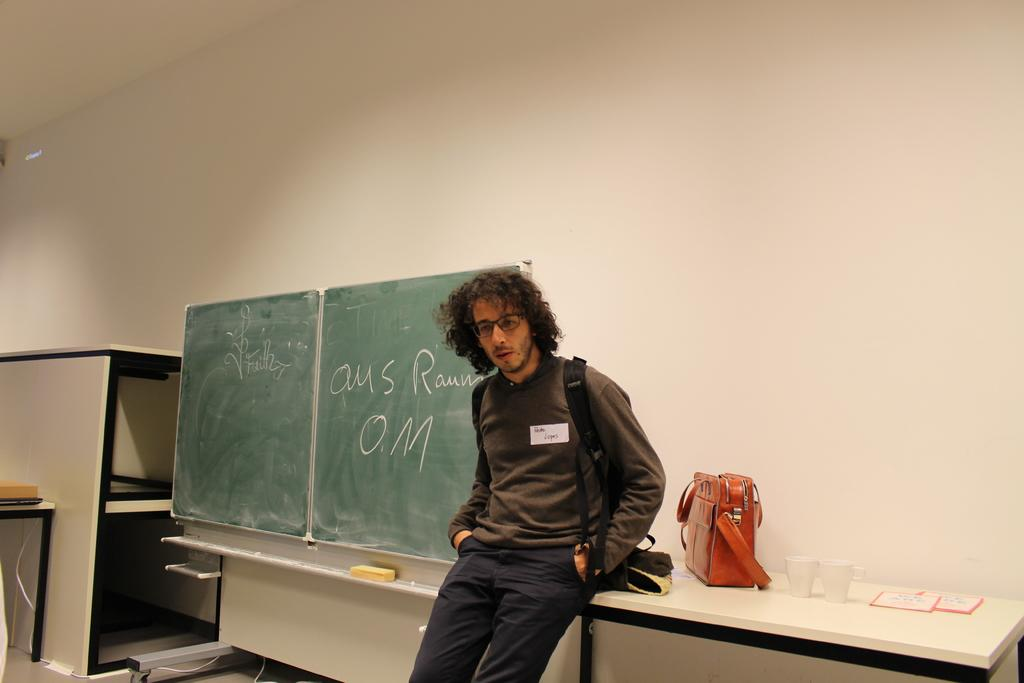What is the person in the image doing? The person is standing. What is the person wearing in the image? The person is wearing a bag and glasses. What can be seen on the table in the image? There are glasses, a paper, and a bag on the table. What type of furniture is present in the image? There is a table and other furniture in the image. What is on the wall behind the person? There is a wall behind the person. What type of cable can be seen connecting the glasses on the table? There is no cable present in the image connecting the glasses on the table. What color is the gold object on the person's wrist in the image? There is no gold object visible on the person's wrist in the image. 